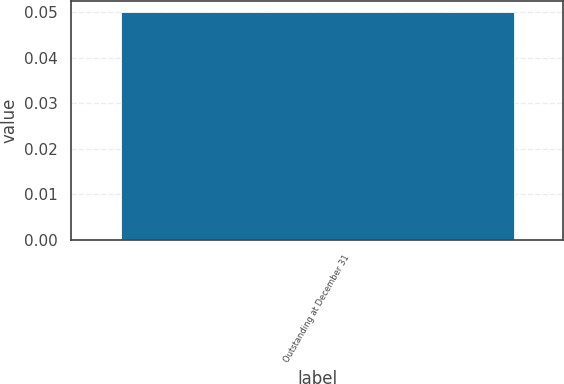Convert chart. <chart><loc_0><loc_0><loc_500><loc_500><bar_chart><fcel>Outstanding at December 31<nl><fcel>0.05<nl></chart> 